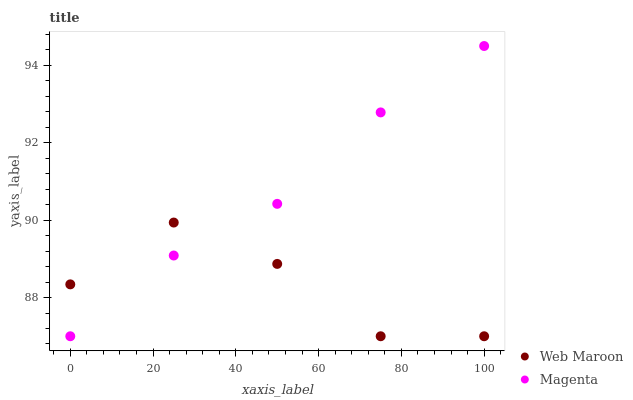Does Web Maroon have the minimum area under the curve?
Answer yes or no. Yes. Does Magenta have the maximum area under the curve?
Answer yes or no. Yes. Does Web Maroon have the maximum area under the curve?
Answer yes or no. No. Is Magenta the smoothest?
Answer yes or no. Yes. Is Web Maroon the roughest?
Answer yes or no. Yes. Is Web Maroon the smoothest?
Answer yes or no. No. Does Magenta have the lowest value?
Answer yes or no. Yes. Does Magenta have the highest value?
Answer yes or no. Yes. Does Web Maroon have the highest value?
Answer yes or no. No. Does Web Maroon intersect Magenta?
Answer yes or no. Yes. Is Web Maroon less than Magenta?
Answer yes or no. No. Is Web Maroon greater than Magenta?
Answer yes or no. No. 